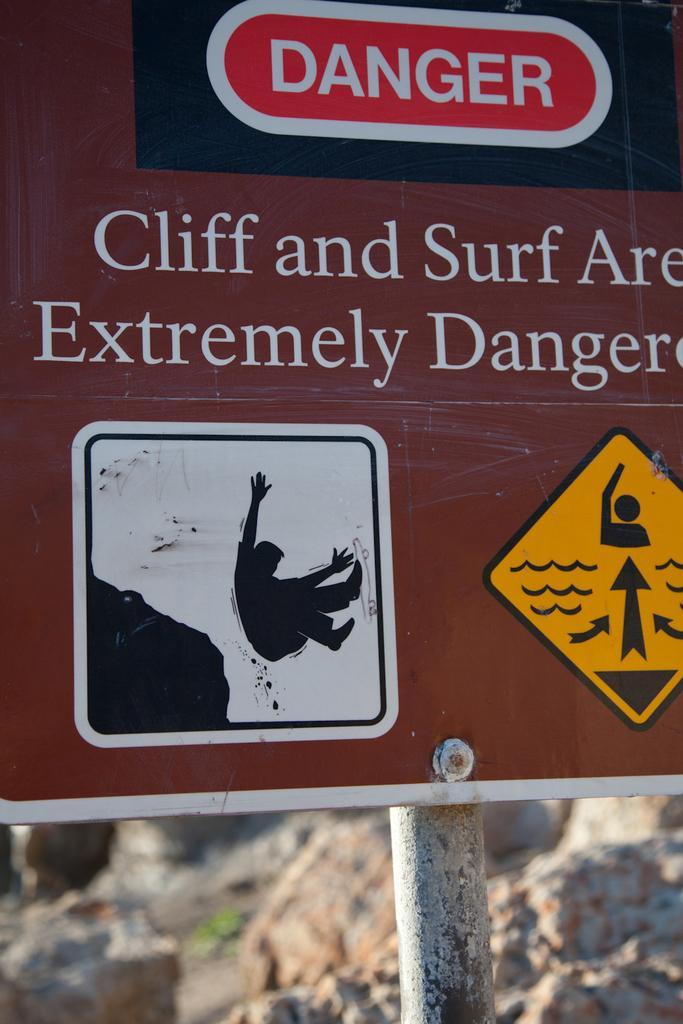Describe this image in one or two sentences. In this image I can see a board which is in brown color attached to a pole, on the board I can see something written on it. Background I can see rocks. 